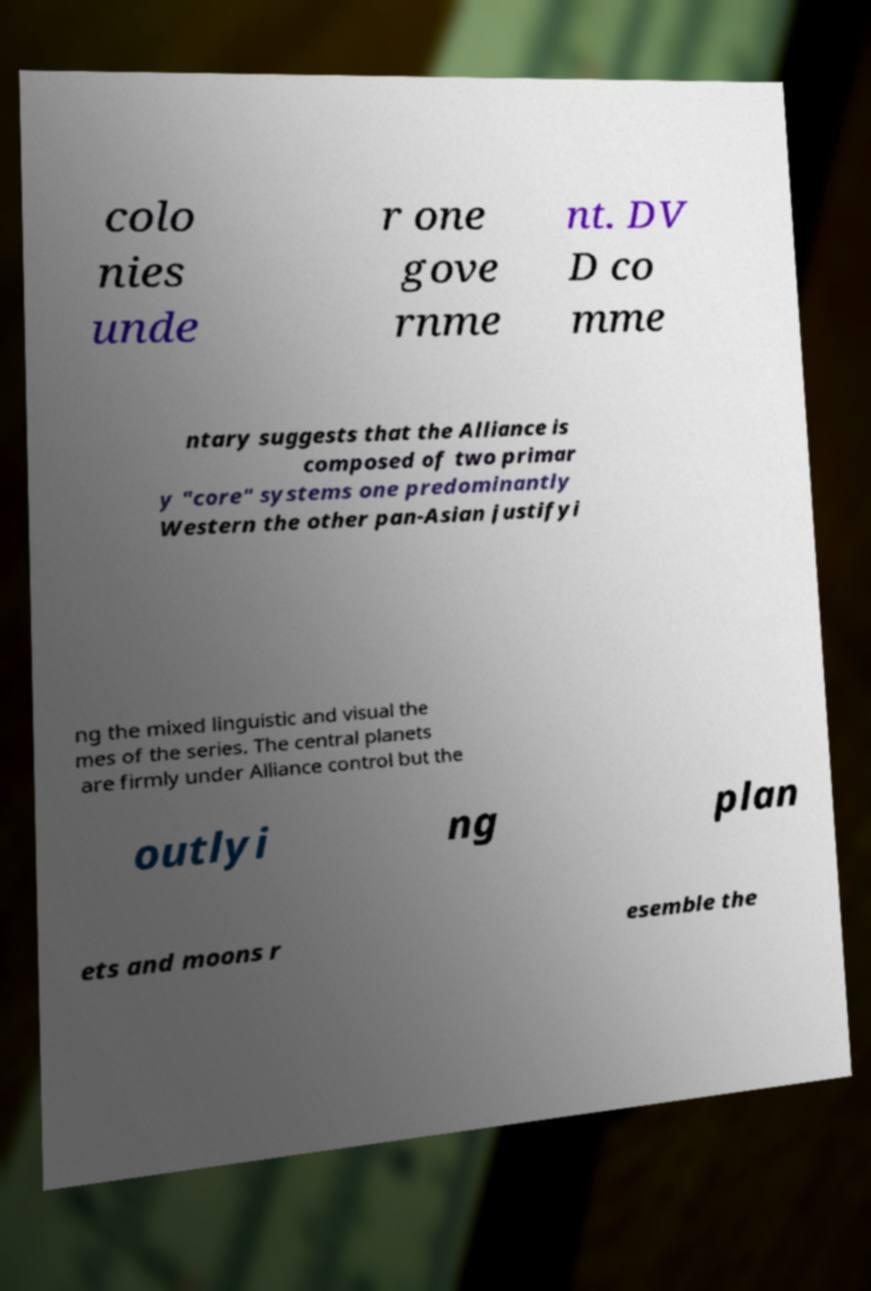Please identify and transcribe the text found in this image. colo nies unde r one gove rnme nt. DV D co mme ntary suggests that the Alliance is composed of two primar y "core" systems one predominantly Western the other pan-Asian justifyi ng the mixed linguistic and visual the mes of the series. The central planets are firmly under Alliance control but the outlyi ng plan ets and moons r esemble the 